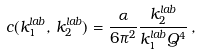<formula> <loc_0><loc_0><loc_500><loc_500>c ( k _ { 1 } ^ { l a b } , \, k _ { 2 } ^ { l a b } ) = \frac { \alpha } { 6 \pi ^ { 2 } } \frac { k ^ { l a b } _ { 2 } } { k _ { 1 } ^ { l a b } Q ^ { 4 } } \, ,</formula> 